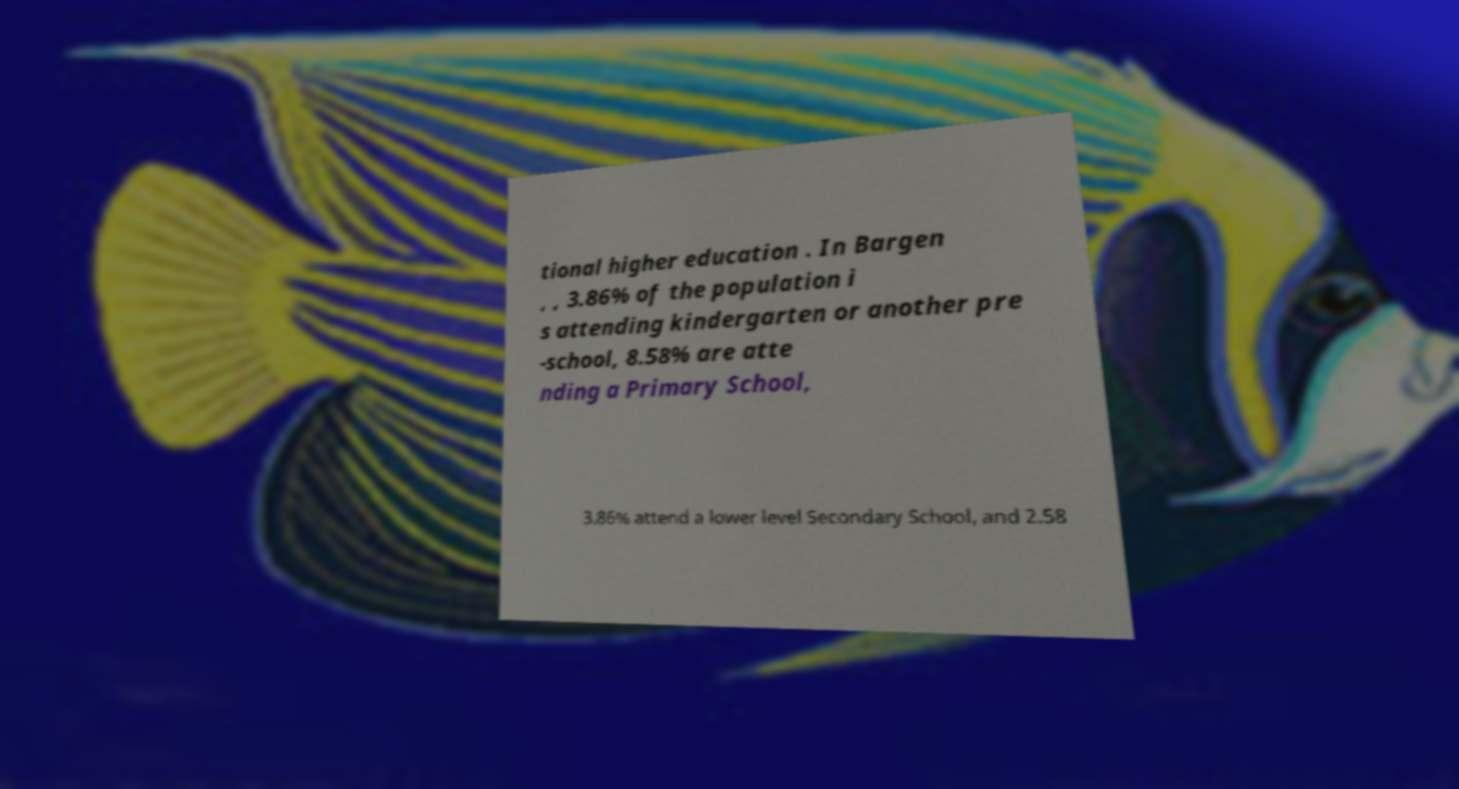For documentation purposes, I need the text within this image transcribed. Could you provide that? tional higher education . In Bargen , , 3.86% of the population i s attending kindergarten or another pre -school, 8.58% are atte nding a Primary School, 3.86% attend a lower level Secondary School, and 2.58 